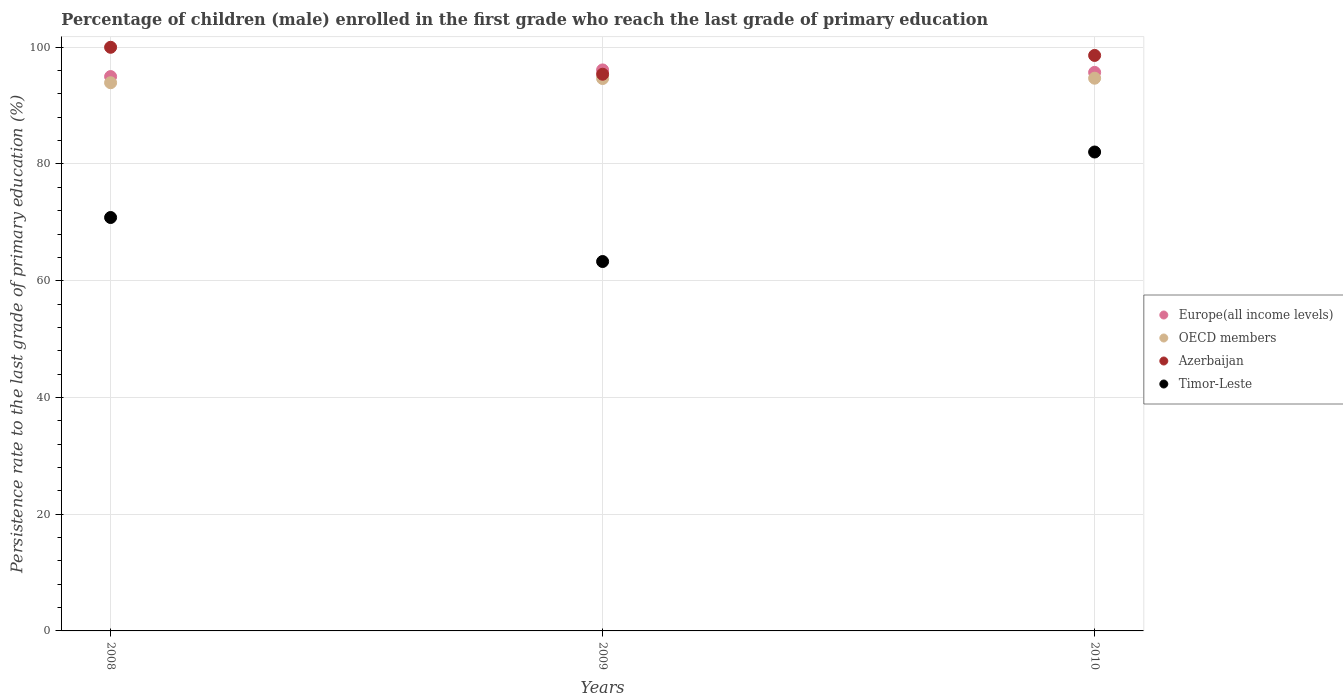Is the number of dotlines equal to the number of legend labels?
Make the answer very short. Yes. What is the persistence rate of children in Timor-Leste in 2009?
Offer a terse response. 63.29. Across all years, what is the maximum persistence rate of children in Europe(all income levels)?
Ensure brevity in your answer.  96.11. Across all years, what is the minimum persistence rate of children in Azerbaijan?
Give a very brief answer. 95.38. In which year was the persistence rate of children in Europe(all income levels) maximum?
Offer a very short reply. 2009. In which year was the persistence rate of children in OECD members minimum?
Give a very brief answer. 2008. What is the total persistence rate of children in Europe(all income levels) in the graph?
Keep it short and to the point. 286.78. What is the difference between the persistence rate of children in OECD members in 2008 and that in 2010?
Offer a terse response. -0.77. What is the difference between the persistence rate of children in Azerbaijan in 2009 and the persistence rate of children in Europe(all income levels) in 2008?
Your answer should be compact. 0.4. What is the average persistence rate of children in Timor-Leste per year?
Provide a succinct answer. 72.06. In the year 2010, what is the difference between the persistence rate of children in Europe(all income levels) and persistence rate of children in Azerbaijan?
Offer a very short reply. -2.91. What is the ratio of the persistence rate of children in Timor-Leste in 2008 to that in 2009?
Give a very brief answer. 1.12. Is the persistence rate of children in Azerbaijan in 2008 less than that in 2010?
Offer a very short reply. No. What is the difference between the highest and the second highest persistence rate of children in OECD members?
Give a very brief answer. 0.05. What is the difference between the highest and the lowest persistence rate of children in OECD members?
Give a very brief answer. 0.77. In how many years, is the persistence rate of children in OECD members greater than the average persistence rate of children in OECD members taken over all years?
Provide a short and direct response. 2. Is the sum of the persistence rate of children in Europe(all income levels) in 2008 and 2010 greater than the maximum persistence rate of children in OECD members across all years?
Offer a terse response. Yes. Is it the case that in every year, the sum of the persistence rate of children in Timor-Leste and persistence rate of children in Azerbaijan  is greater than the persistence rate of children in OECD members?
Make the answer very short. Yes. Is the persistence rate of children in Azerbaijan strictly less than the persistence rate of children in OECD members over the years?
Give a very brief answer. No. How many years are there in the graph?
Offer a terse response. 3. What is the difference between two consecutive major ticks on the Y-axis?
Your response must be concise. 20. Does the graph contain grids?
Provide a short and direct response. Yes. Where does the legend appear in the graph?
Provide a short and direct response. Center right. How many legend labels are there?
Keep it short and to the point. 4. How are the legend labels stacked?
Provide a succinct answer. Vertical. What is the title of the graph?
Your answer should be compact. Percentage of children (male) enrolled in the first grade who reach the last grade of primary education. Does "Peru" appear as one of the legend labels in the graph?
Provide a succinct answer. No. What is the label or title of the X-axis?
Ensure brevity in your answer.  Years. What is the label or title of the Y-axis?
Your answer should be very brief. Persistence rate to the last grade of primary education (%). What is the Persistence rate to the last grade of primary education (%) of Europe(all income levels) in 2008?
Your answer should be compact. 94.98. What is the Persistence rate to the last grade of primary education (%) of OECD members in 2008?
Your response must be concise. 93.92. What is the Persistence rate to the last grade of primary education (%) of Azerbaijan in 2008?
Offer a very short reply. 99.99. What is the Persistence rate to the last grade of primary education (%) in Timor-Leste in 2008?
Ensure brevity in your answer.  70.83. What is the Persistence rate to the last grade of primary education (%) in Europe(all income levels) in 2009?
Give a very brief answer. 96.11. What is the Persistence rate to the last grade of primary education (%) of OECD members in 2009?
Your response must be concise. 94.64. What is the Persistence rate to the last grade of primary education (%) in Azerbaijan in 2009?
Ensure brevity in your answer.  95.38. What is the Persistence rate to the last grade of primary education (%) in Timor-Leste in 2009?
Make the answer very short. 63.29. What is the Persistence rate to the last grade of primary education (%) of Europe(all income levels) in 2010?
Your answer should be compact. 95.69. What is the Persistence rate to the last grade of primary education (%) in OECD members in 2010?
Keep it short and to the point. 94.69. What is the Persistence rate to the last grade of primary education (%) of Azerbaijan in 2010?
Give a very brief answer. 98.6. What is the Persistence rate to the last grade of primary education (%) in Timor-Leste in 2010?
Your answer should be very brief. 82.05. Across all years, what is the maximum Persistence rate to the last grade of primary education (%) in Europe(all income levels)?
Keep it short and to the point. 96.11. Across all years, what is the maximum Persistence rate to the last grade of primary education (%) of OECD members?
Your answer should be very brief. 94.69. Across all years, what is the maximum Persistence rate to the last grade of primary education (%) of Azerbaijan?
Make the answer very short. 99.99. Across all years, what is the maximum Persistence rate to the last grade of primary education (%) in Timor-Leste?
Provide a short and direct response. 82.05. Across all years, what is the minimum Persistence rate to the last grade of primary education (%) of Europe(all income levels)?
Provide a succinct answer. 94.98. Across all years, what is the minimum Persistence rate to the last grade of primary education (%) in OECD members?
Your answer should be very brief. 93.92. Across all years, what is the minimum Persistence rate to the last grade of primary education (%) of Azerbaijan?
Keep it short and to the point. 95.38. Across all years, what is the minimum Persistence rate to the last grade of primary education (%) in Timor-Leste?
Keep it short and to the point. 63.29. What is the total Persistence rate to the last grade of primary education (%) in Europe(all income levels) in the graph?
Make the answer very short. 286.78. What is the total Persistence rate to the last grade of primary education (%) of OECD members in the graph?
Your response must be concise. 283.26. What is the total Persistence rate to the last grade of primary education (%) of Azerbaijan in the graph?
Your answer should be very brief. 293.97. What is the total Persistence rate to the last grade of primary education (%) of Timor-Leste in the graph?
Give a very brief answer. 216.17. What is the difference between the Persistence rate to the last grade of primary education (%) of Europe(all income levels) in 2008 and that in 2009?
Ensure brevity in your answer.  -1.14. What is the difference between the Persistence rate to the last grade of primary education (%) in OECD members in 2008 and that in 2009?
Provide a succinct answer. -0.72. What is the difference between the Persistence rate to the last grade of primary education (%) of Azerbaijan in 2008 and that in 2009?
Your answer should be compact. 4.61. What is the difference between the Persistence rate to the last grade of primary education (%) of Timor-Leste in 2008 and that in 2009?
Your answer should be very brief. 7.54. What is the difference between the Persistence rate to the last grade of primary education (%) of Europe(all income levels) in 2008 and that in 2010?
Offer a very short reply. -0.72. What is the difference between the Persistence rate to the last grade of primary education (%) of OECD members in 2008 and that in 2010?
Your answer should be compact. -0.77. What is the difference between the Persistence rate to the last grade of primary education (%) of Azerbaijan in 2008 and that in 2010?
Your response must be concise. 1.39. What is the difference between the Persistence rate to the last grade of primary education (%) in Timor-Leste in 2008 and that in 2010?
Make the answer very short. -11.22. What is the difference between the Persistence rate to the last grade of primary education (%) of Europe(all income levels) in 2009 and that in 2010?
Offer a terse response. 0.42. What is the difference between the Persistence rate to the last grade of primary education (%) of OECD members in 2009 and that in 2010?
Make the answer very short. -0.05. What is the difference between the Persistence rate to the last grade of primary education (%) in Azerbaijan in 2009 and that in 2010?
Provide a succinct answer. -3.22. What is the difference between the Persistence rate to the last grade of primary education (%) of Timor-Leste in 2009 and that in 2010?
Offer a terse response. -18.76. What is the difference between the Persistence rate to the last grade of primary education (%) in Europe(all income levels) in 2008 and the Persistence rate to the last grade of primary education (%) in OECD members in 2009?
Keep it short and to the point. 0.34. What is the difference between the Persistence rate to the last grade of primary education (%) in Europe(all income levels) in 2008 and the Persistence rate to the last grade of primary education (%) in Azerbaijan in 2009?
Offer a very short reply. -0.4. What is the difference between the Persistence rate to the last grade of primary education (%) in Europe(all income levels) in 2008 and the Persistence rate to the last grade of primary education (%) in Timor-Leste in 2009?
Your response must be concise. 31.69. What is the difference between the Persistence rate to the last grade of primary education (%) of OECD members in 2008 and the Persistence rate to the last grade of primary education (%) of Azerbaijan in 2009?
Offer a very short reply. -1.46. What is the difference between the Persistence rate to the last grade of primary education (%) in OECD members in 2008 and the Persistence rate to the last grade of primary education (%) in Timor-Leste in 2009?
Offer a very short reply. 30.63. What is the difference between the Persistence rate to the last grade of primary education (%) of Azerbaijan in 2008 and the Persistence rate to the last grade of primary education (%) of Timor-Leste in 2009?
Provide a short and direct response. 36.7. What is the difference between the Persistence rate to the last grade of primary education (%) of Europe(all income levels) in 2008 and the Persistence rate to the last grade of primary education (%) of OECD members in 2010?
Offer a terse response. 0.28. What is the difference between the Persistence rate to the last grade of primary education (%) of Europe(all income levels) in 2008 and the Persistence rate to the last grade of primary education (%) of Azerbaijan in 2010?
Your response must be concise. -3.62. What is the difference between the Persistence rate to the last grade of primary education (%) in Europe(all income levels) in 2008 and the Persistence rate to the last grade of primary education (%) in Timor-Leste in 2010?
Ensure brevity in your answer.  12.92. What is the difference between the Persistence rate to the last grade of primary education (%) in OECD members in 2008 and the Persistence rate to the last grade of primary education (%) in Azerbaijan in 2010?
Provide a short and direct response. -4.68. What is the difference between the Persistence rate to the last grade of primary education (%) of OECD members in 2008 and the Persistence rate to the last grade of primary education (%) of Timor-Leste in 2010?
Your response must be concise. 11.87. What is the difference between the Persistence rate to the last grade of primary education (%) of Azerbaijan in 2008 and the Persistence rate to the last grade of primary education (%) of Timor-Leste in 2010?
Provide a succinct answer. 17.94. What is the difference between the Persistence rate to the last grade of primary education (%) of Europe(all income levels) in 2009 and the Persistence rate to the last grade of primary education (%) of OECD members in 2010?
Offer a terse response. 1.42. What is the difference between the Persistence rate to the last grade of primary education (%) of Europe(all income levels) in 2009 and the Persistence rate to the last grade of primary education (%) of Azerbaijan in 2010?
Make the answer very short. -2.48. What is the difference between the Persistence rate to the last grade of primary education (%) of Europe(all income levels) in 2009 and the Persistence rate to the last grade of primary education (%) of Timor-Leste in 2010?
Give a very brief answer. 14.06. What is the difference between the Persistence rate to the last grade of primary education (%) of OECD members in 2009 and the Persistence rate to the last grade of primary education (%) of Azerbaijan in 2010?
Offer a terse response. -3.96. What is the difference between the Persistence rate to the last grade of primary education (%) of OECD members in 2009 and the Persistence rate to the last grade of primary education (%) of Timor-Leste in 2010?
Provide a succinct answer. 12.59. What is the difference between the Persistence rate to the last grade of primary education (%) of Azerbaijan in 2009 and the Persistence rate to the last grade of primary education (%) of Timor-Leste in 2010?
Offer a very short reply. 13.33. What is the average Persistence rate to the last grade of primary education (%) in Europe(all income levels) per year?
Provide a short and direct response. 95.59. What is the average Persistence rate to the last grade of primary education (%) of OECD members per year?
Provide a short and direct response. 94.42. What is the average Persistence rate to the last grade of primary education (%) of Azerbaijan per year?
Your answer should be compact. 97.99. What is the average Persistence rate to the last grade of primary education (%) in Timor-Leste per year?
Your response must be concise. 72.06. In the year 2008, what is the difference between the Persistence rate to the last grade of primary education (%) of Europe(all income levels) and Persistence rate to the last grade of primary education (%) of OECD members?
Keep it short and to the point. 1.05. In the year 2008, what is the difference between the Persistence rate to the last grade of primary education (%) of Europe(all income levels) and Persistence rate to the last grade of primary education (%) of Azerbaijan?
Give a very brief answer. -5.02. In the year 2008, what is the difference between the Persistence rate to the last grade of primary education (%) in Europe(all income levels) and Persistence rate to the last grade of primary education (%) in Timor-Leste?
Offer a terse response. 24.15. In the year 2008, what is the difference between the Persistence rate to the last grade of primary education (%) of OECD members and Persistence rate to the last grade of primary education (%) of Azerbaijan?
Keep it short and to the point. -6.07. In the year 2008, what is the difference between the Persistence rate to the last grade of primary education (%) in OECD members and Persistence rate to the last grade of primary education (%) in Timor-Leste?
Give a very brief answer. 23.09. In the year 2008, what is the difference between the Persistence rate to the last grade of primary education (%) of Azerbaijan and Persistence rate to the last grade of primary education (%) of Timor-Leste?
Your response must be concise. 29.16. In the year 2009, what is the difference between the Persistence rate to the last grade of primary education (%) in Europe(all income levels) and Persistence rate to the last grade of primary education (%) in OECD members?
Make the answer very short. 1.47. In the year 2009, what is the difference between the Persistence rate to the last grade of primary education (%) in Europe(all income levels) and Persistence rate to the last grade of primary education (%) in Azerbaijan?
Your response must be concise. 0.74. In the year 2009, what is the difference between the Persistence rate to the last grade of primary education (%) in Europe(all income levels) and Persistence rate to the last grade of primary education (%) in Timor-Leste?
Offer a terse response. 32.83. In the year 2009, what is the difference between the Persistence rate to the last grade of primary education (%) of OECD members and Persistence rate to the last grade of primary education (%) of Azerbaijan?
Provide a short and direct response. -0.74. In the year 2009, what is the difference between the Persistence rate to the last grade of primary education (%) of OECD members and Persistence rate to the last grade of primary education (%) of Timor-Leste?
Your answer should be very brief. 31.35. In the year 2009, what is the difference between the Persistence rate to the last grade of primary education (%) of Azerbaijan and Persistence rate to the last grade of primary education (%) of Timor-Leste?
Your response must be concise. 32.09. In the year 2010, what is the difference between the Persistence rate to the last grade of primary education (%) in Europe(all income levels) and Persistence rate to the last grade of primary education (%) in OECD members?
Make the answer very short. 1. In the year 2010, what is the difference between the Persistence rate to the last grade of primary education (%) in Europe(all income levels) and Persistence rate to the last grade of primary education (%) in Azerbaijan?
Provide a succinct answer. -2.91. In the year 2010, what is the difference between the Persistence rate to the last grade of primary education (%) of Europe(all income levels) and Persistence rate to the last grade of primary education (%) of Timor-Leste?
Give a very brief answer. 13.64. In the year 2010, what is the difference between the Persistence rate to the last grade of primary education (%) in OECD members and Persistence rate to the last grade of primary education (%) in Azerbaijan?
Keep it short and to the point. -3.9. In the year 2010, what is the difference between the Persistence rate to the last grade of primary education (%) in OECD members and Persistence rate to the last grade of primary education (%) in Timor-Leste?
Your response must be concise. 12.64. In the year 2010, what is the difference between the Persistence rate to the last grade of primary education (%) of Azerbaijan and Persistence rate to the last grade of primary education (%) of Timor-Leste?
Provide a succinct answer. 16.55. What is the ratio of the Persistence rate to the last grade of primary education (%) in Europe(all income levels) in 2008 to that in 2009?
Provide a short and direct response. 0.99. What is the ratio of the Persistence rate to the last grade of primary education (%) of Azerbaijan in 2008 to that in 2009?
Your answer should be very brief. 1.05. What is the ratio of the Persistence rate to the last grade of primary education (%) of Timor-Leste in 2008 to that in 2009?
Provide a succinct answer. 1.12. What is the ratio of the Persistence rate to the last grade of primary education (%) in Azerbaijan in 2008 to that in 2010?
Provide a succinct answer. 1.01. What is the ratio of the Persistence rate to the last grade of primary education (%) in Timor-Leste in 2008 to that in 2010?
Provide a short and direct response. 0.86. What is the ratio of the Persistence rate to the last grade of primary education (%) in Europe(all income levels) in 2009 to that in 2010?
Your answer should be very brief. 1. What is the ratio of the Persistence rate to the last grade of primary education (%) of OECD members in 2009 to that in 2010?
Offer a very short reply. 1. What is the ratio of the Persistence rate to the last grade of primary education (%) in Azerbaijan in 2009 to that in 2010?
Make the answer very short. 0.97. What is the ratio of the Persistence rate to the last grade of primary education (%) of Timor-Leste in 2009 to that in 2010?
Provide a succinct answer. 0.77. What is the difference between the highest and the second highest Persistence rate to the last grade of primary education (%) in Europe(all income levels)?
Your answer should be compact. 0.42. What is the difference between the highest and the second highest Persistence rate to the last grade of primary education (%) of OECD members?
Keep it short and to the point. 0.05. What is the difference between the highest and the second highest Persistence rate to the last grade of primary education (%) of Azerbaijan?
Your answer should be compact. 1.39. What is the difference between the highest and the second highest Persistence rate to the last grade of primary education (%) in Timor-Leste?
Provide a short and direct response. 11.22. What is the difference between the highest and the lowest Persistence rate to the last grade of primary education (%) of Europe(all income levels)?
Your answer should be compact. 1.14. What is the difference between the highest and the lowest Persistence rate to the last grade of primary education (%) in OECD members?
Provide a short and direct response. 0.77. What is the difference between the highest and the lowest Persistence rate to the last grade of primary education (%) of Azerbaijan?
Provide a succinct answer. 4.61. What is the difference between the highest and the lowest Persistence rate to the last grade of primary education (%) of Timor-Leste?
Your answer should be compact. 18.76. 